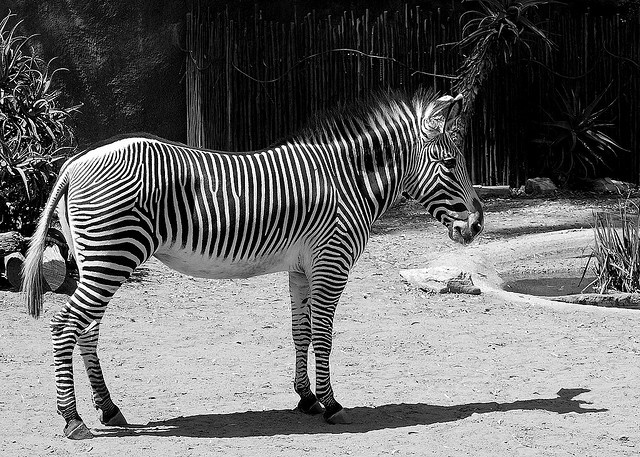Describe the objects in this image and their specific colors. I can see a zebra in black, lightgray, gray, and darkgray tones in this image. 